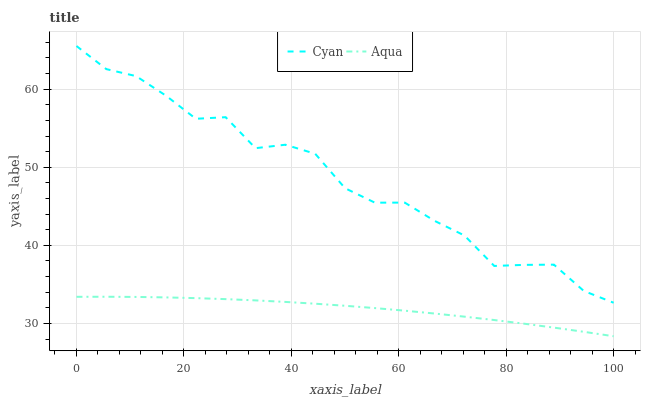Does Aqua have the minimum area under the curve?
Answer yes or no. Yes. Does Cyan have the maximum area under the curve?
Answer yes or no. Yes. Does Aqua have the maximum area under the curve?
Answer yes or no. No. Is Aqua the smoothest?
Answer yes or no. Yes. Is Cyan the roughest?
Answer yes or no. Yes. Is Aqua the roughest?
Answer yes or no. No. Does Aqua have the lowest value?
Answer yes or no. Yes. Does Cyan have the highest value?
Answer yes or no. Yes. Does Aqua have the highest value?
Answer yes or no. No. Is Aqua less than Cyan?
Answer yes or no. Yes. Is Cyan greater than Aqua?
Answer yes or no. Yes. Does Aqua intersect Cyan?
Answer yes or no. No. 